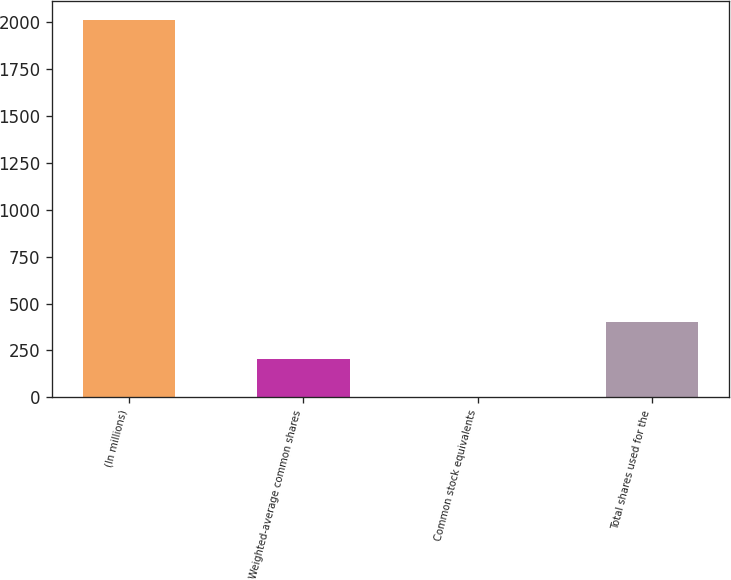<chart> <loc_0><loc_0><loc_500><loc_500><bar_chart><fcel>(In millions)<fcel>Weighted-average common shares<fcel>Common stock equivalents<fcel>Total shares used for the<nl><fcel>2012<fcel>202.73<fcel>1.7<fcel>403.76<nl></chart> 